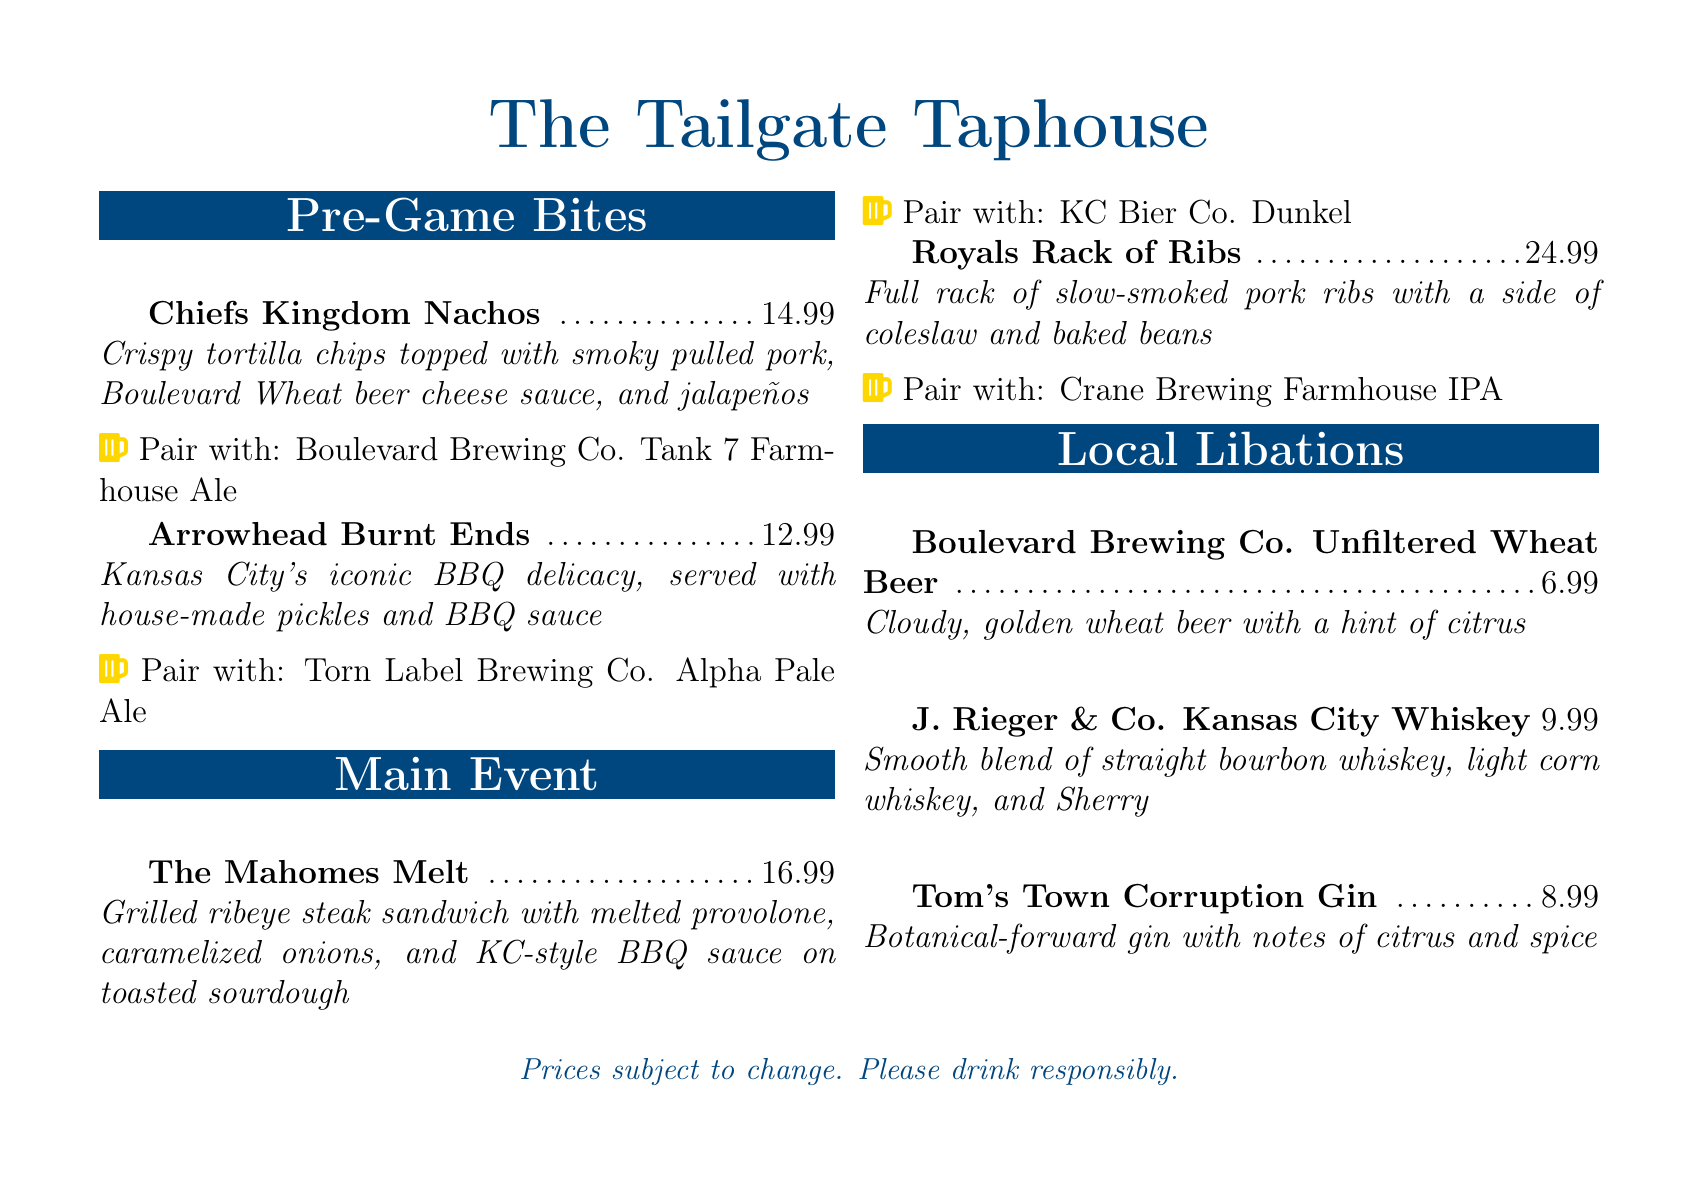What are the Chiefs Kingdom Nachos topped with? The Chiefs Kingdom Nachos are topped with smoky pulled pork, Boulevard Wheat beer cheese sauce, and jalapeños.
Answer: smoky pulled pork, Boulevard Wheat beer cheese sauce, and jalapeños How much do the Arrowhead Burnt Ends cost? The price of Arrowhead Burnt Ends is listed in the document.
Answer: 12.99 Which local beer is suggested to pair with The Mahomes Melt? The document specifies a pairing for The Mahomes Melt.
Answer: KC Bier Co. Dunkel What type of whiskey does J. Rieger & Co. produce? The document describes J. Rieger & Co. whiskey as a smooth blend of straight bourbon whiskey, light corn whiskey, and Sherry.
Answer: straight bourbon whiskey, light corn whiskey, and Sherry How many items are in the Local Libations section? The Local Libations section contains a listing of beverages.
Answer: 3 What is the price of Tom's Town Corruption Gin? The price of Tom's Town Corruption Gin is provided in the menu.
Answer: 8.99 What is the main ingredient in Boulevard Brewing Co. Unfiltered Wheat Beer? The document mentions the main characteristics of the beer, highlighting it as a golden wheat beer.
Answer: golden wheat What type of cuisine is featured in the Main Event section? The Main Event section highlights specific dishes that are associated with a particular culinary style.
Answer: Kansas City-style What is the price of the Royals Rack of Ribs? The price for the Royals Rack of Ribs is stated in the menu.
Answer: 24.99 